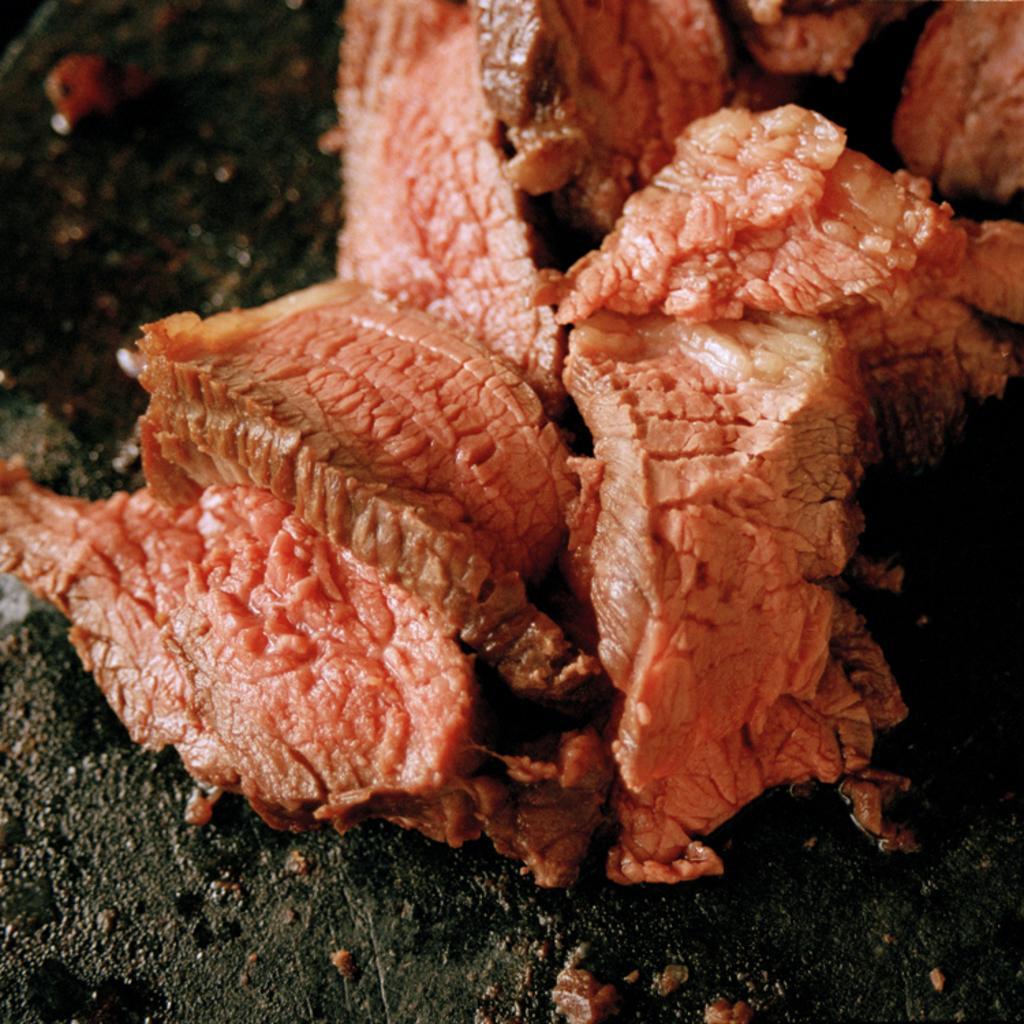In one or two sentences, can you explain what this image depicts? This image consists of flesh in red color is kept on the ground. 